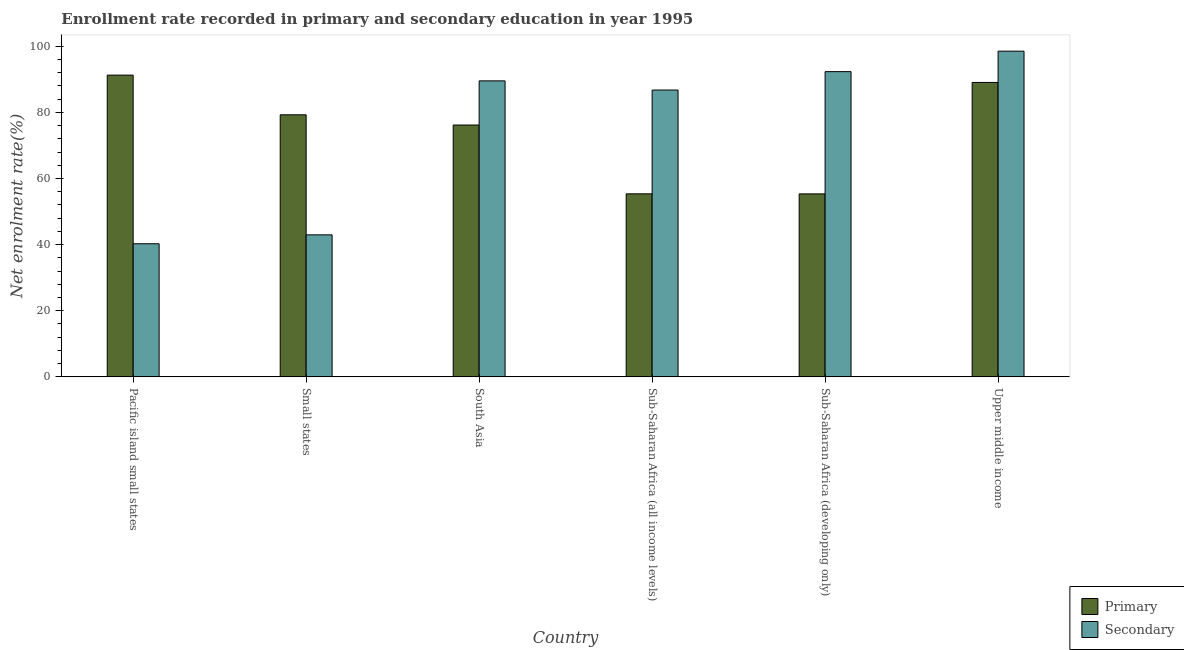Are the number of bars on each tick of the X-axis equal?
Make the answer very short. Yes. How many bars are there on the 2nd tick from the left?
Your answer should be very brief. 2. What is the label of the 5th group of bars from the left?
Your answer should be very brief. Sub-Saharan Africa (developing only). What is the enrollment rate in secondary education in Pacific island small states?
Make the answer very short. 40.27. Across all countries, what is the maximum enrollment rate in primary education?
Keep it short and to the point. 91.29. Across all countries, what is the minimum enrollment rate in primary education?
Your response must be concise. 55.36. In which country was the enrollment rate in primary education maximum?
Offer a very short reply. Pacific island small states. In which country was the enrollment rate in secondary education minimum?
Your answer should be compact. Pacific island small states. What is the total enrollment rate in secondary education in the graph?
Keep it short and to the point. 450.43. What is the difference between the enrollment rate in secondary education in Pacific island small states and that in Sub-Saharan Africa (all income levels)?
Your answer should be very brief. -46.5. What is the difference between the enrollment rate in secondary education in Sub-Saharan Africa (developing only) and the enrollment rate in primary education in South Asia?
Offer a very short reply. 16.16. What is the average enrollment rate in primary education per country?
Your answer should be compact. 74.43. What is the difference between the enrollment rate in secondary education and enrollment rate in primary education in Upper middle income?
Provide a short and direct response. 9.46. What is the ratio of the enrollment rate in secondary education in South Asia to that in Sub-Saharan Africa (developing only)?
Your answer should be compact. 0.97. Is the enrollment rate in secondary education in South Asia less than that in Sub-Saharan Africa (developing only)?
Your answer should be compact. Yes. What is the difference between the highest and the second highest enrollment rate in primary education?
Ensure brevity in your answer.  2.22. What is the difference between the highest and the lowest enrollment rate in secondary education?
Offer a very short reply. 58.26. In how many countries, is the enrollment rate in primary education greater than the average enrollment rate in primary education taken over all countries?
Make the answer very short. 4. What does the 1st bar from the left in Sub-Saharan Africa (all income levels) represents?
Make the answer very short. Primary. What does the 1st bar from the right in Sub-Saharan Africa (all income levels) represents?
Provide a short and direct response. Secondary. How many bars are there?
Ensure brevity in your answer.  12. How many countries are there in the graph?
Offer a very short reply. 6. Does the graph contain any zero values?
Your response must be concise. No. Does the graph contain grids?
Your answer should be very brief. No. Where does the legend appear in the graph?
Ensure brevity in your answer.  Bottom right. How many legend labels are there?
Offer a terse response. 2. How are the legend labels stacked?
Keep it short and to the point. Vertical. What is the title of the graph?
Keep it short and to the point. Enrollment rate recorded in primary and secondary education in year 1995. What is the label or title of the Y-axis?
Your answer should be compact. Net enrolment rate(%). What is the Net enrolment rate(%) in Primary in Pacific island small states?
Your answer should be very brief. 91.29. What is the Net enrolment rate(%) in Secondary in Pacific island small states?
Make the answer very short. 40.27. What is the Net enrolment rate(%) of Primary in Small states?
Ensure brevity in your answer.  79.28. What is the Net enrolment rate(%) in Secondary in Small states?
Your answer should be very brief. 42.97. What is the Net enrolment rate(%) in Primary in South Asia?
Provide a succinct answer. 76.19. What is the Net enrolment rate(%) of Secondary in South Asia?
Give a very brief answer. 89.55. What is the Net enrolment rate(%) in Primary in Sub-Saharan Africa (all income levels)?
Give a very brief answer. 55.37. What is the Net enrolment rate(%) in Secondary in Sub-Saharan Africa (all income levels)?
Offer a very short reply. 86.77. What is the Net enrolment rate(%) of Primary in Sub-Saharan Africa (developing only)?
Ensure brevity in your answer.  55.36. What is the Net enrolment rate(%) in Secondary in Sub-Saharan Africa (developing only)?
Provide a succinct answer. 92.34. What is the Net enrolment rate(%) of Primary in Upper middle income?
Give a very brief answer. 89.07. What is the Net enrolment rate(%) in Secondary in Upper middle income?
Make the answer very short. 98.53. Across all countries, what is the maximum Net enrolment rate(%) in Primary?
Provide a succinct answer. 91.29. Across all countries, what is the maximum Net enrolment rate(%) of Secondary?
Provide a short and direct response. 98.53. Across all countries, what is the minimum Net enrolment rate(%) in Primary?
Ensure brevity in your answer.  55.36. Across all countries, what is the minimum Net enrolment rate(%) of Secondary?
Your response must be concise. 40.27. What is the total Net enrolment rate(%) in Primary in the graph?
Provide a succinct answer. 446.55. What is the total Net enrolment rate(%) in Secondary in the graph?
Provide a succinct answer. 450.43. What is the difference between the Net enrolment rate(%) of Primary in Pacific island small states and that in Small states?
Offer a terse response. 12.01. What is the difference between the Net enrolment rate(%) of Secondary in Pacific island small states and that in Small states?
Offer a very short reply. -2.7. What is the difference between the Net enrolment rate(%) of Primary in Pacific island small states and that in South Asia?
Offer a terse response. 15.1. What is the difference between the Net enrolment rate(%) of Secondary in Pacific island small states and that in South Asia?
Offer a terse response. -49.28. What is the difference between the Net enrolment rate(%) in Primary in Pacific island small states and that in Sub-Saharan Africa (all income levels)?
Provide a succinct answer. 35.91. What is the difference between the Net enrolment rate(%) in Secondary in Pacific island small states and that in Sub-Saharan Africa (all income levels)?
Give a very brief answer. -46.5. What is the difference between the Net enrolment rate(%) in Primary in Pacific island small states and that in Sub-Saharan Africa (developing only)?
Offer a very short reply. 35.93. What is the difference between the Net enrolment rate(%) of Secondary in Pacific island small states and that in Sub-Saharan Africa (developing only)?
Provide a succinct answer. -52.07. What is the difference between the Net enrolment rate(%) in Primary in Pacific island small states and that in Upper middle income?
Give a very brief answer. 2.22. What is the difference between the Net enrolment rate(%) in Secondary in Pacific island small states and that in Upper middle income?
Ensure brevity in your answer.  -58.26. What is the difference between the Net enrolment rate(%) in Primary in Small states and that in South Asia?
Provide a succinct answer. 3.09. What is the difference between the Net enrolment rate(%) in Secondary in Small states and that in South Asia?
Offer a very short reply. -46.58. What is the difference between the Net enrolment rate(%) in Primary in Small states and that in Sub-Saharan Africa (all income levels)?
Offer a very short reply. 23.91. What is the difference between the Net enrolment rate(%) in Secondary in Small states and that in Sub-Saharan Africa (all income levels)?
Give a very brief answer. -43.8. What is the difference between the Net enrolment rate(%) of Primary in Small states and that in Sub-Saharan Africa (developing only)?
Make the answer very short. 23.92. What is the difference between the Net enrolment rate(%) of Secondary in Small states and that in Sub-Saharan Africa (developing only)?
Your response must be concise. -49.38. What is the difference between the Net enrolment rate(%) in Primary in Small states and that in Upper middle income?
Keep it short and to the point. -9.79. What is the difference between the Net enrolment rate(%) of Secondary in Small states and that in Upper middle income?
Give a very brief answer. -55.57. What is the difference between the Net enrolment rate(%) of Primary in South Asia and that in Sub-Saharan Africa (all income levels)?
Offer a terse response. 20.81. What is the difference between the Net enrolment rate(%) in Secondary in South Asia and that in Sub-Saharan Africa (all income levels)?
Provide a short and direct response. 2.78. What is the difference between the Net enrolment rate(%) of Primary in South Asia and that in Sub-Saharan Africa (developing only)?
Ensure brevity in your answer.  20.83. What is the difference between the Net enrolment rate(%) in Secondary in South Asia and that in Sub-Saharan Africa (developing only)?
Make the answer very short. -2.79. What is the difference between the Net enrolment rate(%) in Primary in South Asia and that in Upper middle income?
Ensure brevity in your answer.  -12.88. What is the difference between the Net enrolment rate(%) in Secondary in South Asia and that in Upper middle income?
Keep it short and to the point. -8.99. What is the difference between the Net enrolment rate(%) of Primary in Sub-Saharan Africa (all income levels) and that in Sub-Saharan Africa (developing only)?
Make the answer very short. 0.02. What is the difference between the Net enrolment rate(%) in Secondary in Sub-Saharan Africa (all income levels) and that in Sub-Saharan Africa (developing only)?
Ensure brevity in your answer.  -5.57. What is the difference between the Net enrolment rate(%) of Primary in Sub-Saharan Africa (all income levels) and that in Upper middle income?
Keep it short and to the point. -33.7. What is the difference between the Net enrolment rate(%) in Secondary in Sub-Saharan Africa (all income levels) and that in Upper middle income?
Make the answer very short. -11.76. What is the difference between the Net enrolment rate(%) of Primary in Sub-Saharan Africa (developing only) and that in Upper middle income?
Provide a short and direct response. -33.72. What is the difference between the Net enrolment rate(%) in Secondary in Sub-Saharan Africa (developing only) and that in Upper middle income?
Ensure brevity in your answer.  -6.19. What is the difference between the Net enrolment rate(%) of Primary in Pacific island small states and the Net enrolment rate(%) of Secondary in Small states?
Make the answer very short. 48.32. What is the difference between the Net enrolment rate(%) in Primary in Pacific island small states and the Net enrolment rate(%) in Secondary in South Asia?
Offer a very short reply. 1.74. What is the difference between the Net enrolment rate(%) in Primary in Pacific island small states and the Net enrolment rate(%) in Secondary in Sub-Saharan Africa (all income levels)?
Ensure brevity in your answer.  4.52. What is the difference between the Net enrolment rate(%) in Primary in Pacific island small states and the Net enrolment rate(%) in Secondary in Sub-Saharan Africa (developing only)?
Make the answer very short. -1.05. What is the difference between the Net enrolment rate(%) in Primary in Pacific island small states and the Net enrolment rate(%) in Secondary in Upper middle income?
Your response must be concise. -7.25. What is the difference between the Net enrolment rate(%) of Primary in Small states and the Net enrolment rate(%) of Secondary in South Asia?
Keep it short and to the point. -10.27. What is the difference between the Net enrolment rate(%) in Primary in Small states and the Net enrolment rate(%) in Secondary in Sub-Saharan Africa (all income levels)?
Offer a terse response. -7.49. What is the difference between the Net enrolment rate(%) of Primary in Small states and the Net enrolment rate(%) of Secondary in Sub-Saharan Africa (developing only)?
Keep it short and to the point. -13.06. What is the difference between the Net enrolment rate(%) in Primary in Small states and the Net enrolment rate(%) in Secondary in Upper middle income?
Your answer should be very brief. -19.26. What is the difference between the Net enrolment rate(%) in Primary in South Asia and the Net enrolment rate(%) in Secondary in Sub-Saharan Africa (all income levels)?
Your answer should be compact. -10.58. What is the difference between the Net enrolment rate(%) of Primary in South Asia and the Net enrolment rate(%) of Secondary in Sub-Saharan Africa (developing only)?
Your answer should be very brief. -16.16. What is the difference between the Net enrolment rate(%) of Primary in South Asia and the Net enrolment rate(%) of Secondary in Upper middle income?
Offer a very short reply. -22.35. What is the difference between the Net enrolment rate(%) in Primary in Sub-Saharan Africa (all income levels) and the Net enrolment rate(%) in Secondary in Sub-Saharan Africa (developing only)?
Your answer should be compact. -36.97. What is the difference between the Net enrolment rate(%) in Primary in Sub-Saharan Africa (all income levels) and the Net enrolment rate(%) in Secondary in Upper middle income?
Your answer should be very brief. -43.16. What is the difference between the Net enrolment rate(%) in Primary in Sub-Saharan Africa (developing only) and the Net enrolment rate(%) in Secondary in Upper middle income?
Ensure brevity in your answer.  -43.18. What is the average Net enrolment rate(%) of Primary per country?
Ensure brevity in your answer.  74.43. What is the average Net enrolment rate(%) in Secondary per country?
Your answer should be compact. 75.07. What is the difference between the Net enrolment rate(%) in Primary and Net enrolment rate(%) in Secondary in Pacific island small states?
Provide a succinct answer. 51.02. What is the difference between the Net enrolment rate(%) in Primary and Net enrolment rate(%) in Secondary in Small states?
Provide a short and direct response. 36.31. What is the difference between the Net enrolment rate(%) in Primary and Net enrolment rate(%) in Secondary in South Asia?
Provide a short and direct response. -13.36. What is the difference between the Net enrolment rate(%) of Primary and Net enrolment rate(%) of Secondary in Sub-Saharan Africa (all income levels)?
Provide a succinct answer. -31.4. What is the difference between the Net enrolment rate(%) in Primary and Net enrolment rate(%) in Secondary in Sub-Saharan Africa (developing only)?
Give a very brief answer. -36.99. What is the difference between the Net enrolment rate(%) in Primary and Net enrolment rate(%) in Secondary in Upper middle income?
Offer a very short reply. -9.46. What is the ratio of the Net enrolment rate(%) of Primary in Pacific island small states to that in Small states?
Offer a very short reply. 1.15. What is the ratio of the Net enrolment rate(%) in Secondary in Pacific island small states to that in Small states?
Provide a succinct answer. 0.94. What is the ratio of the Net enrolment rate(%) of Primary in Pacific island small states to that in South Asia?
Provide a succinct answer. 1.2. What is the ratio of the Net enrolment rate(%) in Secondary in Pacific island small states to that in South Asia?
Give a very brief answer. 0.45. What is the ratio of the Net enrolment rate(%) in Primary in Pacific island small states to that in Sub-Saharan Africa (all income levels)?
Offer a terse response. 1.65. What is the ratio of the Net enrolment rate(%) of Secondary in Pacific island small states to that in Sub-Saharan Africa (all income levels)?
Keep it short and to the point. 0.46. What is the ratio of the Net enrolment rate(%) in Primary in Pacific island small states to that in Sub-Saharan Africa (developing only)?
Ensure brevity in your answer.  1.65. What is the ratio of the Net enrolment rate(%) in Secondary in Pacific island small states to that in Sub-Saharan Africa (developing only)?
Provide a short and direct response. 0.44. What is the ratio of the Net enrolment rate(%) of Primary in Pacific island small states to that in Upper middle income?
Provide a short and direct response. 1.02. What is the ratio of the Net enrolment rate(%) of Secondary in Pacific island small states to that in Upper middle income?
Give a very brief answer. 0.41. What is the ratio of the Net enrolment rate(%) of Primary in Small states to that in South Asia?
Provide a succinct answer. 1.04. What is the ratio of the Net enrolment rate(%) in Secondary in Small states to that in South Asia?
Your response must be concise. 0.48. What is the ratio of the Net enrolment rate(%) in Primary in Small states to that in Sub-Saharan Africa (all income levels)?
Offer a very short reply. 1.43. What is the ratio of the Net enrolment rate(%) of Secondary in Small states to that in Sub-Saharan Africa (all income levels)?
Provide a short and direct response. 0.5. What is the ratio of the Net enrolment rate(%) of Primary in Small states to that in Sub-Saharan Africa (developing only)?
Ensure brevity in your answer.  1.43. What is the ratio of the Net enrolment rate(%) in Secondary in Small states to that in Sub-Saharan Africa (developing only)?
Ensure brevity in your answer.  0.47. What is the ratio of the Net enrolment rate(%) in Primary in Small states to that in Upper middle income?
Your answer should be very brief. 0.89. What is the ratio of the Net enrolment rate(%) in Secondary in Small states to that in Upper middle income?
Ensure brevity in your answer.  0.44. What is the ratio of the Net enrolment rate(%) in Primary in South Asia to that in Sub-Saharan Africa (all income levels)?
Keep it short and to the point. 1.38. What is the ratio of the Net enrolment rate(%) in Secondary in South Asia to that in Sub-Saharan Africa (all income levels)?
Provide a succinct answer. 1.03. What is the ratio of the Net enrolment rate(%) in Primary in South Asia to that in Sub-Saharan Africa (developing only)?
Keep it short and to the point. 1.38. What is the ratio of the Net enrolment rate(%) in Secondary in South Asia to that in Sub-Saharan Africa (developing only)?
Your answer should be compact. 0.97. What is the ratio of the Net enrolment rate(%) of Primary in South Asia to that in Upper middle income?
Your answer should be very brief. 0.86. What is the ratio of the Net enrolment rate(%) of Secondary in South Asia to that in Upper middle income?
Ensure brevity in your answer.  0.91. What is the ratio of the Net enrolment rate(%) of Secondary in Sub-Saharan Africa (all income levels) to that in Sub-Saharan Africa (developing only)?
Ensure brevity in your answer.  0.94. What is the ratio of the Net enrolment rate(%) of Primary in Sub-Saharan Africa (all income levels) to that in Upper middle income?
Give a very brief answer. 0.62. What is the ratio of the Net enrolment rate(%) of Secondary in Sub-Saharan Africa (all income levels) to that in Upper middle income?
Provide a succinct answer. 0.88. What is the ratio of the Net enrolment rate(%) in Primary in Sub-Saharan Africa (developing only) to that in Upper middle income?
Offer a very short reply. 0.62. What is the ratio of the Net enrolment rate(%) in Secondary in Sub-Saharan Africa (developing only) to that in Upper middle income?
Offer a very short reply. 0.94. What is the difference between the highest and the second highest Net enrolment rate(%) of Primary?
Your answer should be compact. 2.22. What is the difference between the highest and the second highest Net enrolment rate(%) in Secondary?
Keep it short and to the point. 6.19. What is the difference between the highest and the lowest Net enrolment rate(%) in Primary?
Provide a short and direct response. 35.93. What is the difference between the highest and the lowest Net enrolment rate(%) in Secondary?
Your response must be concise. 58.26. 